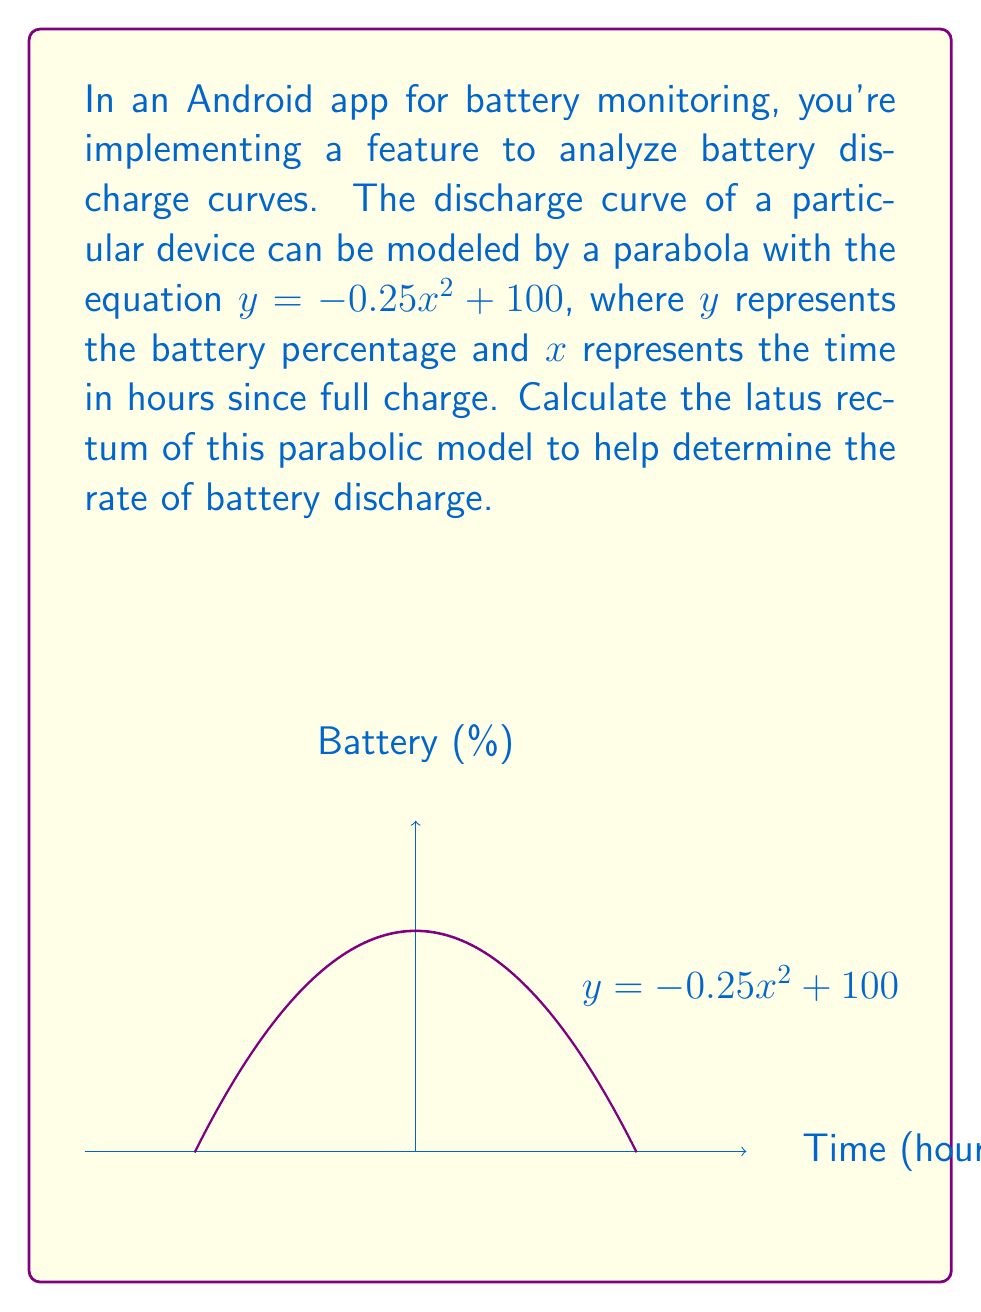Solve this math problem. Let's approach this step-by-step:

1) The general equation of a parabola with vertex at $(0,k)$ is:
   $y = a(x-h)^2 + k$

2) In our case, the equation is $y = -0.25x^2 + 100$, so:
   $a = -0.25$
   $h = 0$
   $k = 100$

3) The latus rectum of a parabola is a line segment that:
   - Passes through the focus
   - Is perpendicular to the axis of symmetry
   - Has both endpoints on the parabola

4) The length of the latus rectum is given by the formula:
   $L = \frac{4}{|a|}$

5) Substituting our value of $a$:
   $L = \frac{4}{|-0.25|} = \frac{4}{0.25} = 16$

Therefore, the latus rectum of this parabolic battery discharge model is 16 hours long.
Answer: $16$ hours 